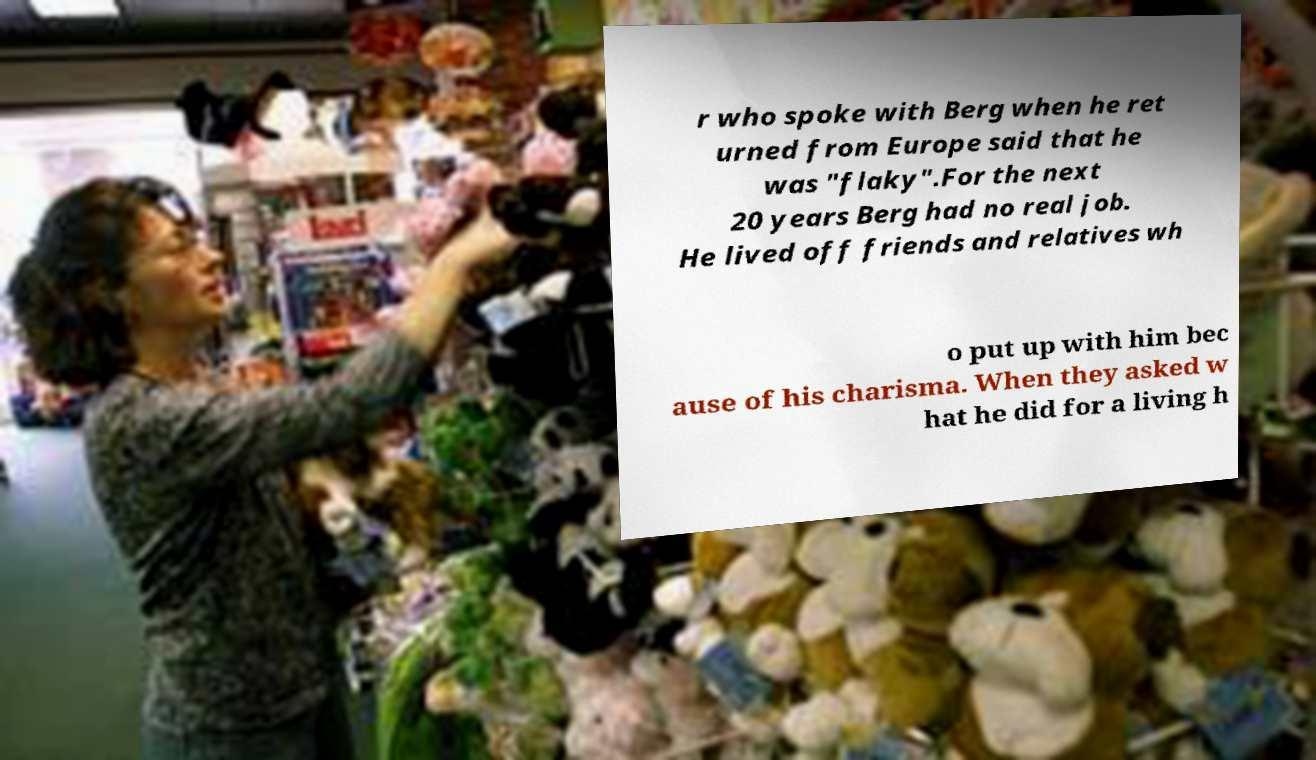Can you accurately transcribe the text from the provided image for me? r who spoke with Berg when he ret urned from Europe said that he was "flaky".For the next 20 years Berg had no real job. He lived off friends and relatives wh o put up with him bec ause of his charisma. When they asked w hat he did for a living h 